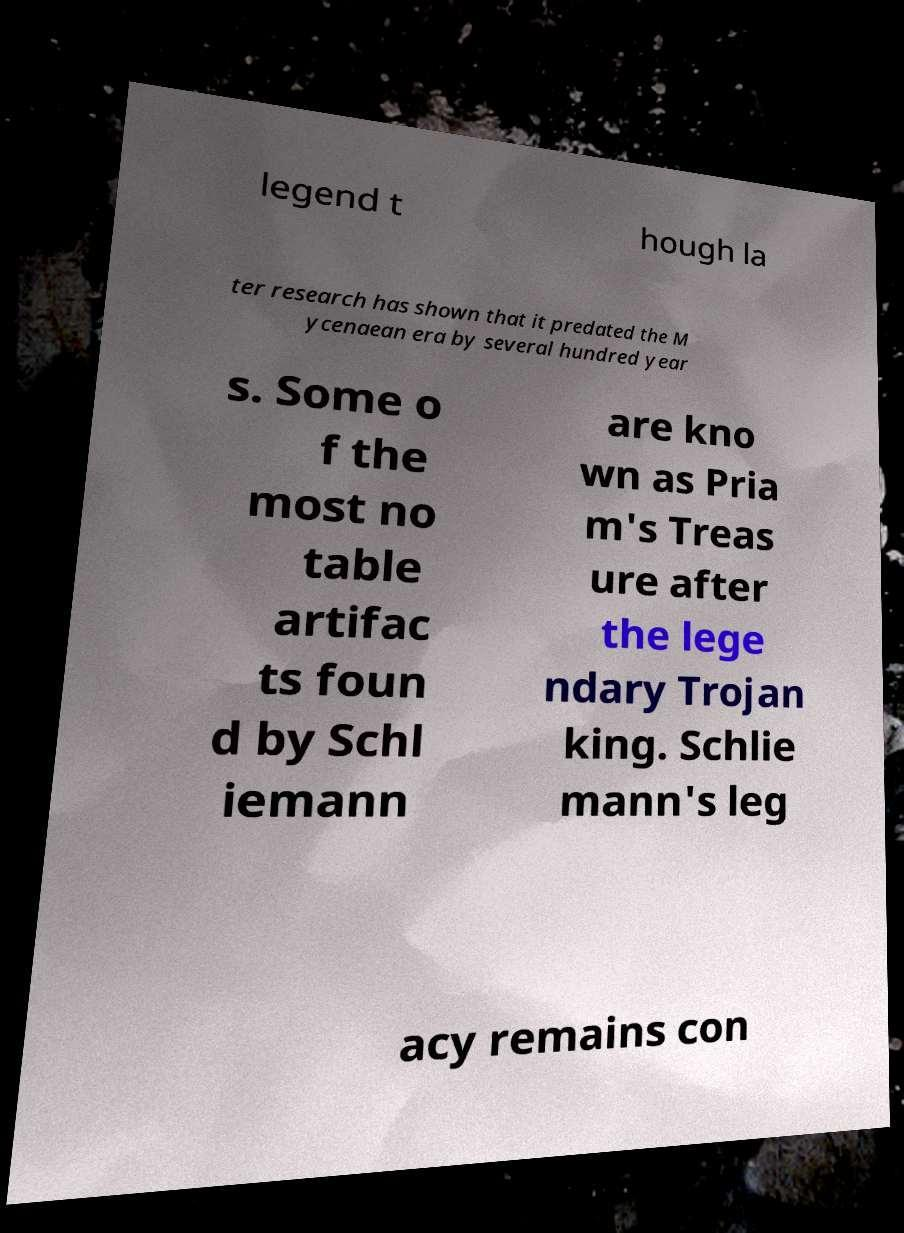There's text embedded in this image that I need extracted. Can you transcribe it verbatim? legend t hough la ter research has shown that it predated the M ycenaean era by several hundred year s. Some o f the most no table artifac ts foun d by Schl iemann are kno wn as Pria m's Treas ure after the lege ndary Trojan king. Schlie mann's leg acy remains con 